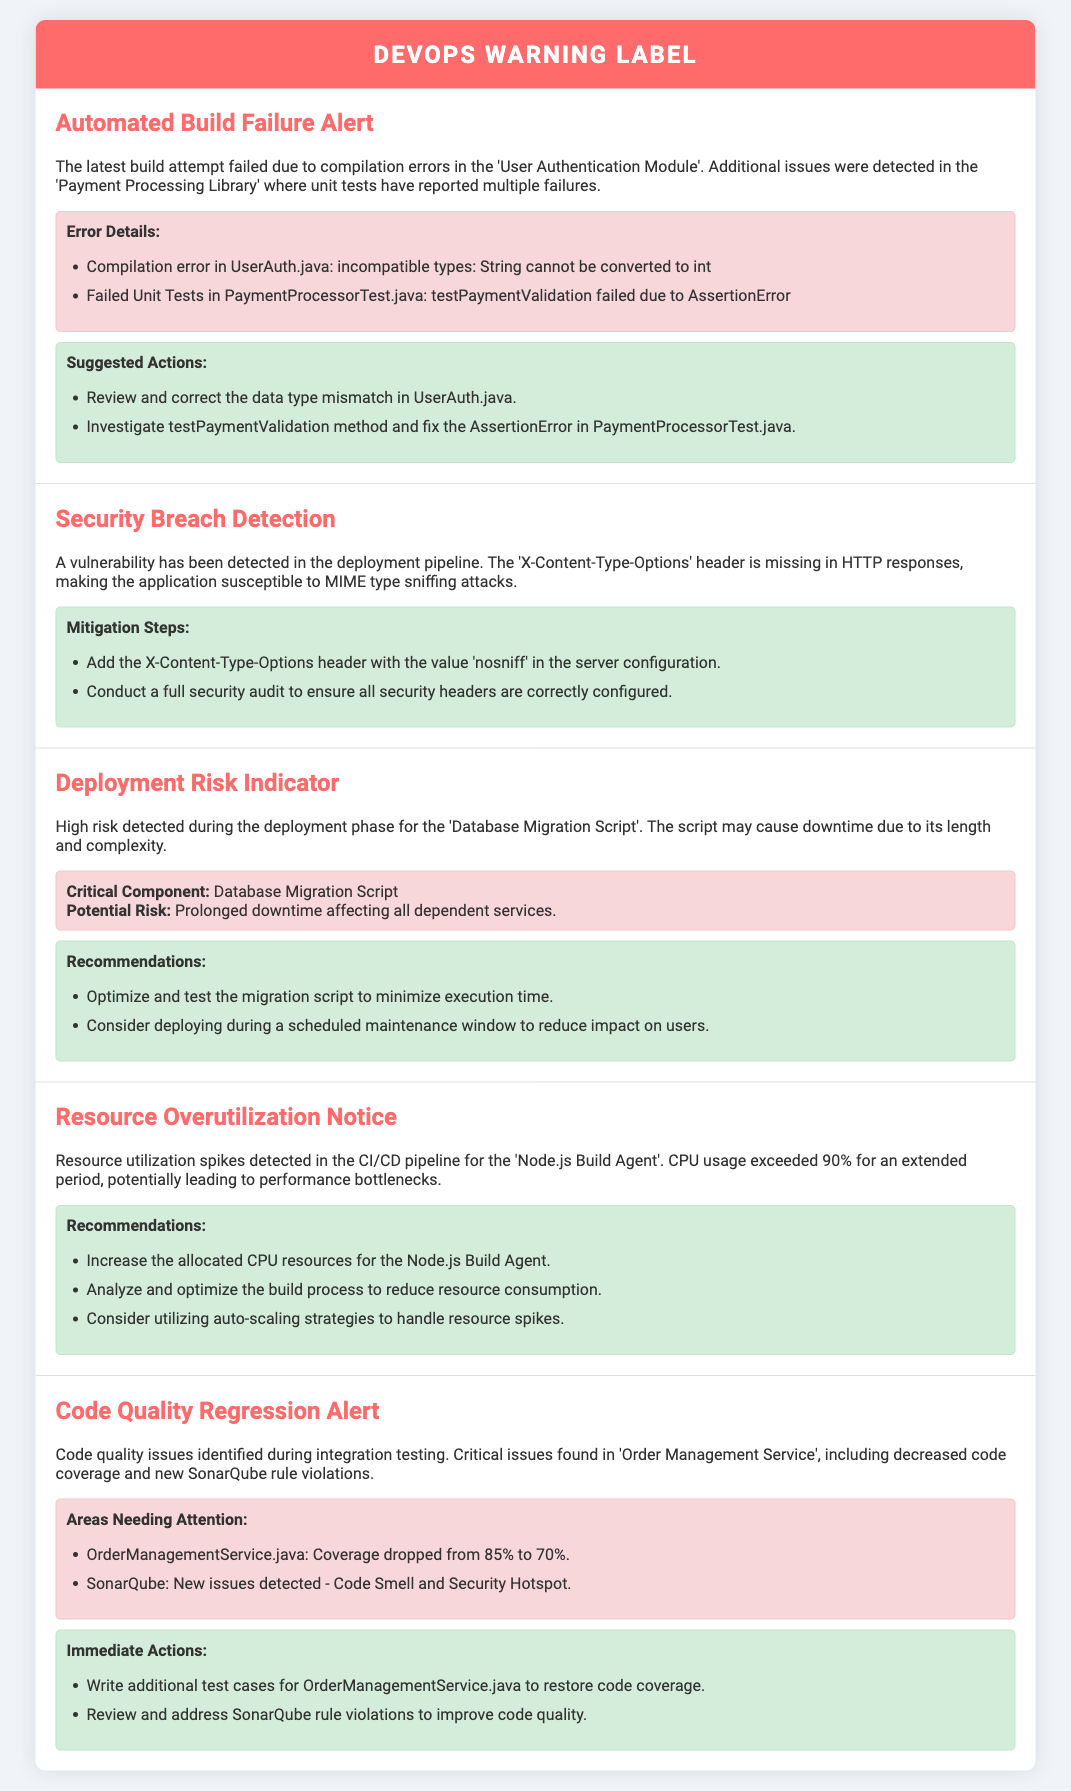What caused the latest build failure? The document states that the build attempt failed due to compilation errors in the 'User Authentication Module' and additional issues in the 'Payment Processing Library'.
Answer: compilation errors What is the missing security header? The document mentions that the 'X-Content-Type-Options' header is missing in HTTP responses.
Answer: X-Content-Type-Options What is the critical component mentioned in the deployment risk indicator? The document identifies the 'Database Migration Script' as the critical component with high risk during deployment.
Answer: Database Migration Script How much did the code coverage drop for OrderManagementService.java? The document states that the coverage dropped from 85% to 70%.
Answer: 15% What should be added to mitigate the security vulnerability? The document suggests adding the X-Content-Type-Options header with the value 'nosniff'.
Answer: nosniff What action is recommended to optimize the CI/CD resource usage? The document recommends increasing the allocated CPU resources for the Node.js Build Agent.
Answer: Increase CPU resources Which module reported multiple unit test failures? The document specifies that multiple failures were reported in the 'Payment Processing Library'.
Answer: Payment Processing Library What immediate action is suggested for OrderManagementService.java? The document states that additional test cases should be written to restore code coverage.
Answer: Write additional test cases What is the status of the automated build attempt? The document indicates that the latest build attempt was unsuccessful due to errors.
Answer: unsuccessful What vulnerability was detected in the deployment pipeline? The document highlights that the application is susceptible to MIME type sniffing attacks.
Answer: MIME type sniffing 